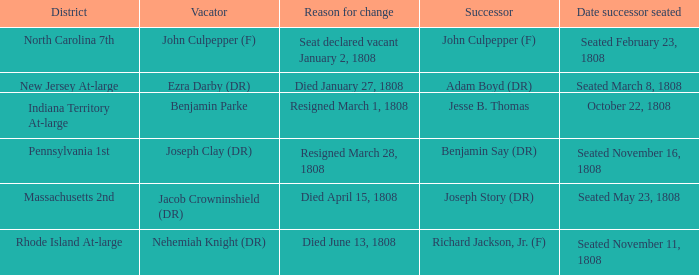How many vacators have October 22, 1808 as date successor seated? 1.0. 